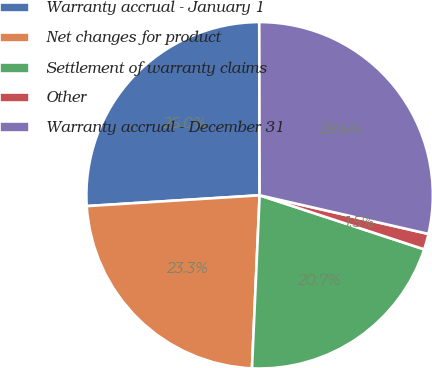<chart> <loc_0><loc_0><loc_500><loc_500><pie_chart><fcel>Warranty accrual - January 1<fcel>Net changes for product<fcel>Settlement of warranty claims<fcel>Other<fcel>Warranty accrual - December 31<nl><fcel>25.96%<fcel>23.3%<fcel>20.65%<fcel>1.47%<fcel>28.61%<nl></chart> 